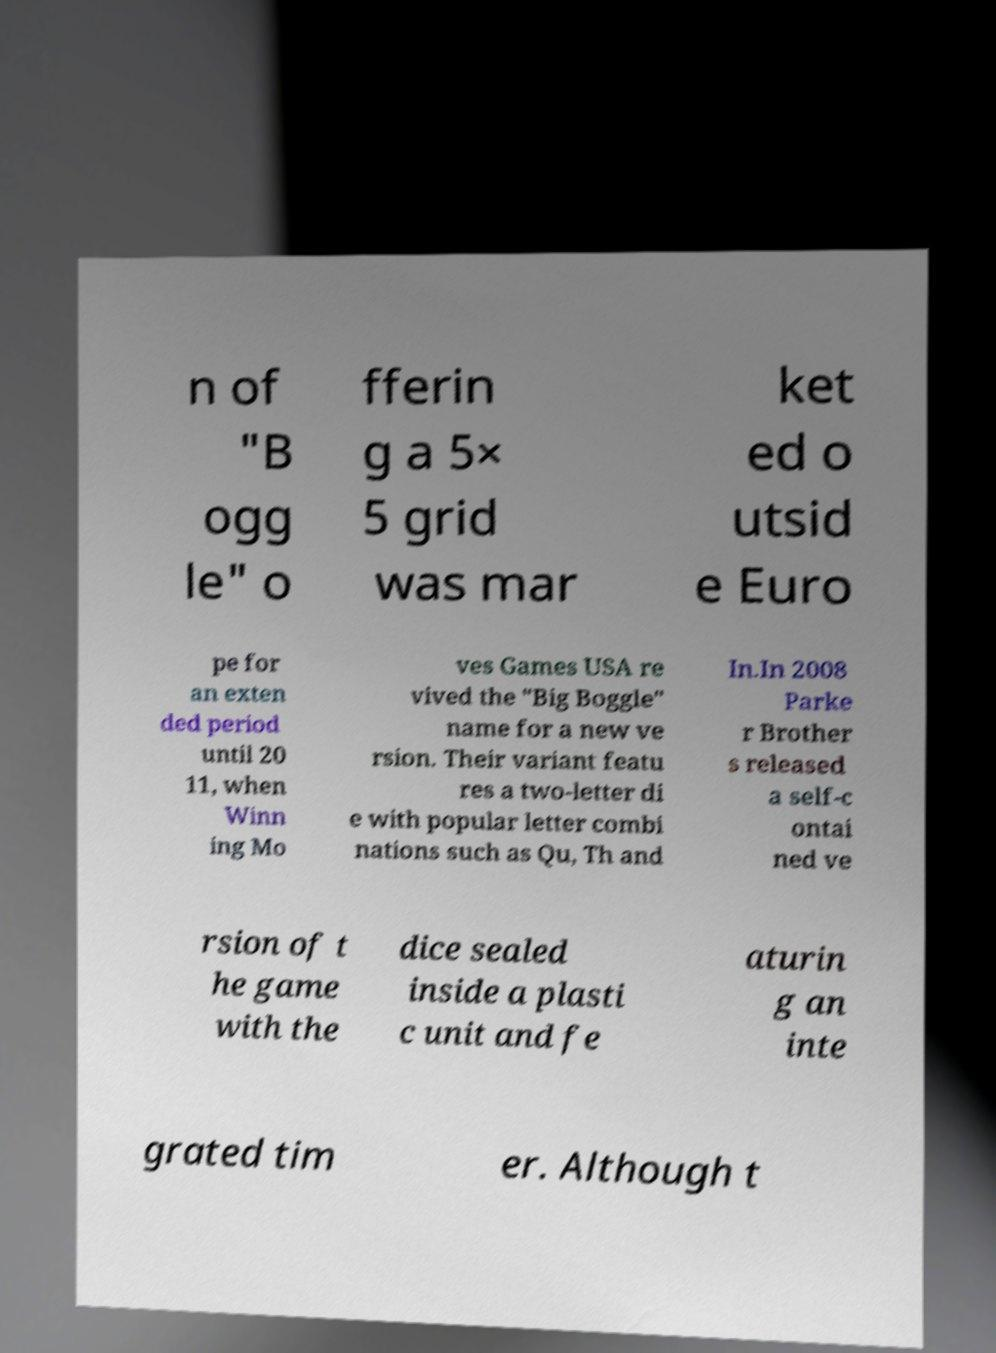For documentation purposes, I need the text within this image transcribed. Could you provide that? n of "B ogg le" o fferin g a 5× 5 grid was mar ket ed o utsid e Euro pe for an exten ded period until 20 11, when Winn ing Mo ves Games USA re vived the "Big Boggle" name for a new ve rsion. Their variant featu res a two-letter di e with popular letter combi nations such as Qu, Th and In.In 2008 Parke r Brother s released a self-c ontai ned ve rsion of t he game with the dice sealed inside a plasti c unit and fe aturin g an inte grated tim er. Although t 